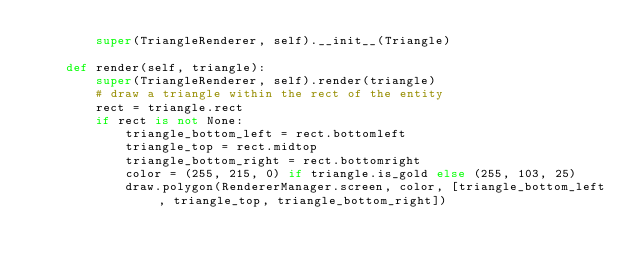<code> <loc_0><loc_0><loc_500><loc_500><_Python_>        super(TriangleRenderer, self).__init__(Triangle)

    def render(self, triangle):
        super(TriangleRenderer, self).render(triangle)
        # draw a triangle within the rect of the entity
        rect = triangle.rect
        if rect is not None:
            triangle_bottom_left = rect.bottomleft
            triangle_top = rect.midtop
            triangle_bottom_right = rect.bottomright
            color = (255, 215, 0) if triangle.is_gold else (255, 103, 25)
            draw.polygon(RendererManager.screen, color, [triangle_bottom_left, triangle_top, triangle_bottom_right])
</code> 